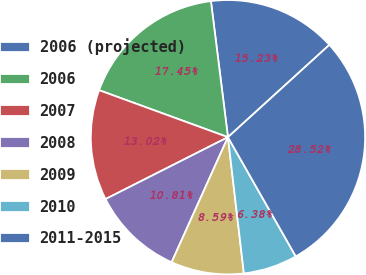Convert chart to OTSL. <chart><loc_0><loc_0><loc_500><loc_500><pie_chart><fcel>2006 (projected)<fcel>2006<fcel>2007<fcel>2008<fcel>2009<fcel>2010<fcel>2011-2015<nl><fcel>15.23%<fcel>17.45%<fcel>13.02%<fcel>10.81%<fcel>8.59%<fcel>6.38%<fcel>28.52%<nl></chart> 